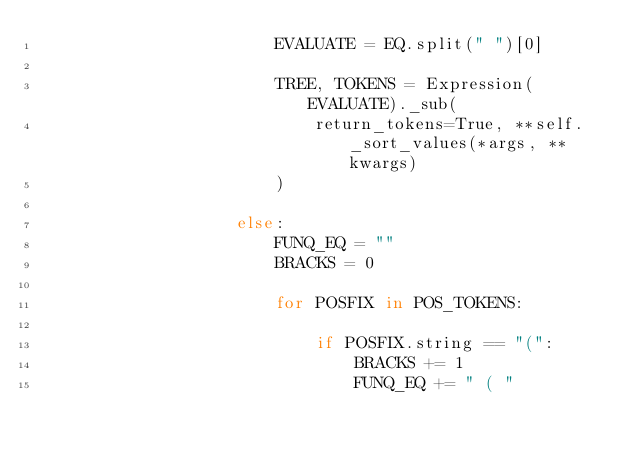<code> <loc_0><loc_0><loc_500><loc_500><_Python_>                        EVALUATE = EQ.split(" ")[0]

                        TREE, TOKENS = Expression(EVALUATE)._sub(
                            return_tokens=True, **self._sort_values(*args, **kwargs)
                        )

                    else:
                        FUNQ_EQ = ""
                        BRACKS = 0

                        for POSFIX in POS_TOKENS:

                            if POSFIX.string == "(":
                                BRACKS += 1
                                FUNQ_EQ += " ( "</code> 